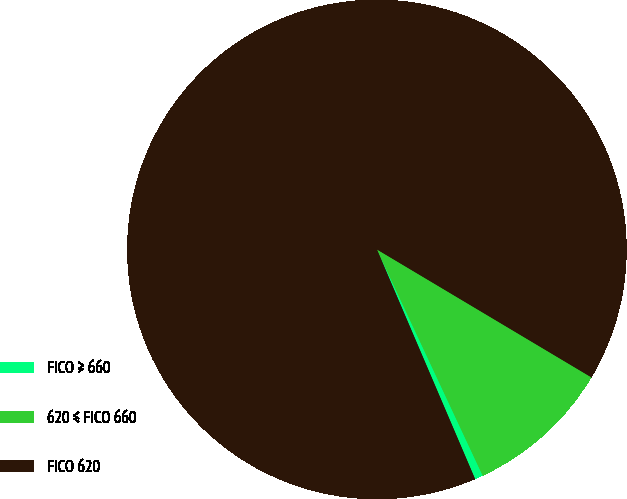Convert chart. <chart><loc_0><loc_0><loc_500><loc_500><pie_chart><fcel>FICO ≥ 660<fcel>620 ≤ FICO 660<fcel>FICO 620<nl><fcel>0.53%<fcel>9.48%<fcel>89.99%<nl></chart> 